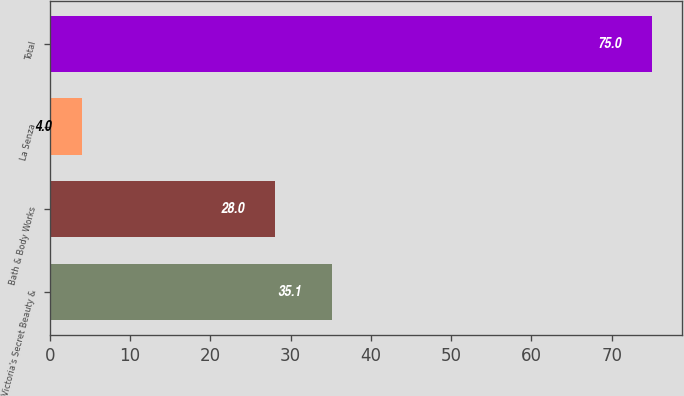Convert chart to OTSL. <chart><loc_0><loc_0><loc_500><loc_500><bar_chart><fcel>Victoria's Secret Beauty &<fcel>Bath & Body Works<fcel>La Senza<fcel>Total<nl><fcel>35.1<fcel>28<fcel>4<fcel>75<nl></chart> 